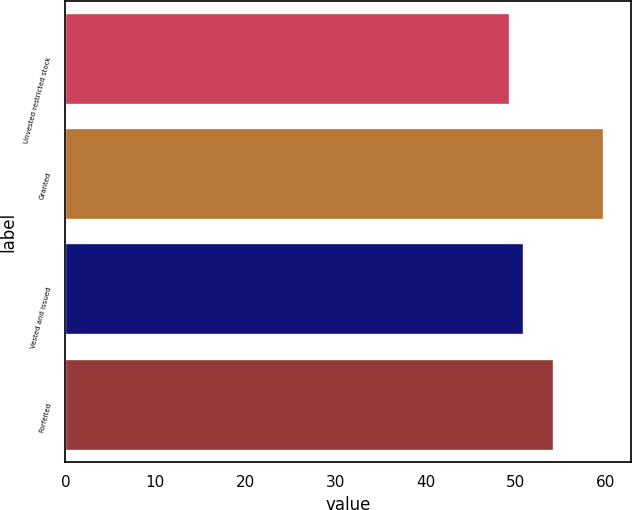<chart> <loc_0><loc_0><loc_500><loc_500><bar_chart><fcel>Unvested restricted stock<fcel>Granted<fcel>Vested and issued<fcel>Forfeited<nl><fcel>49.41<fcel>59.84<fcel>50.96<fcel>54.28<nl></chart> 